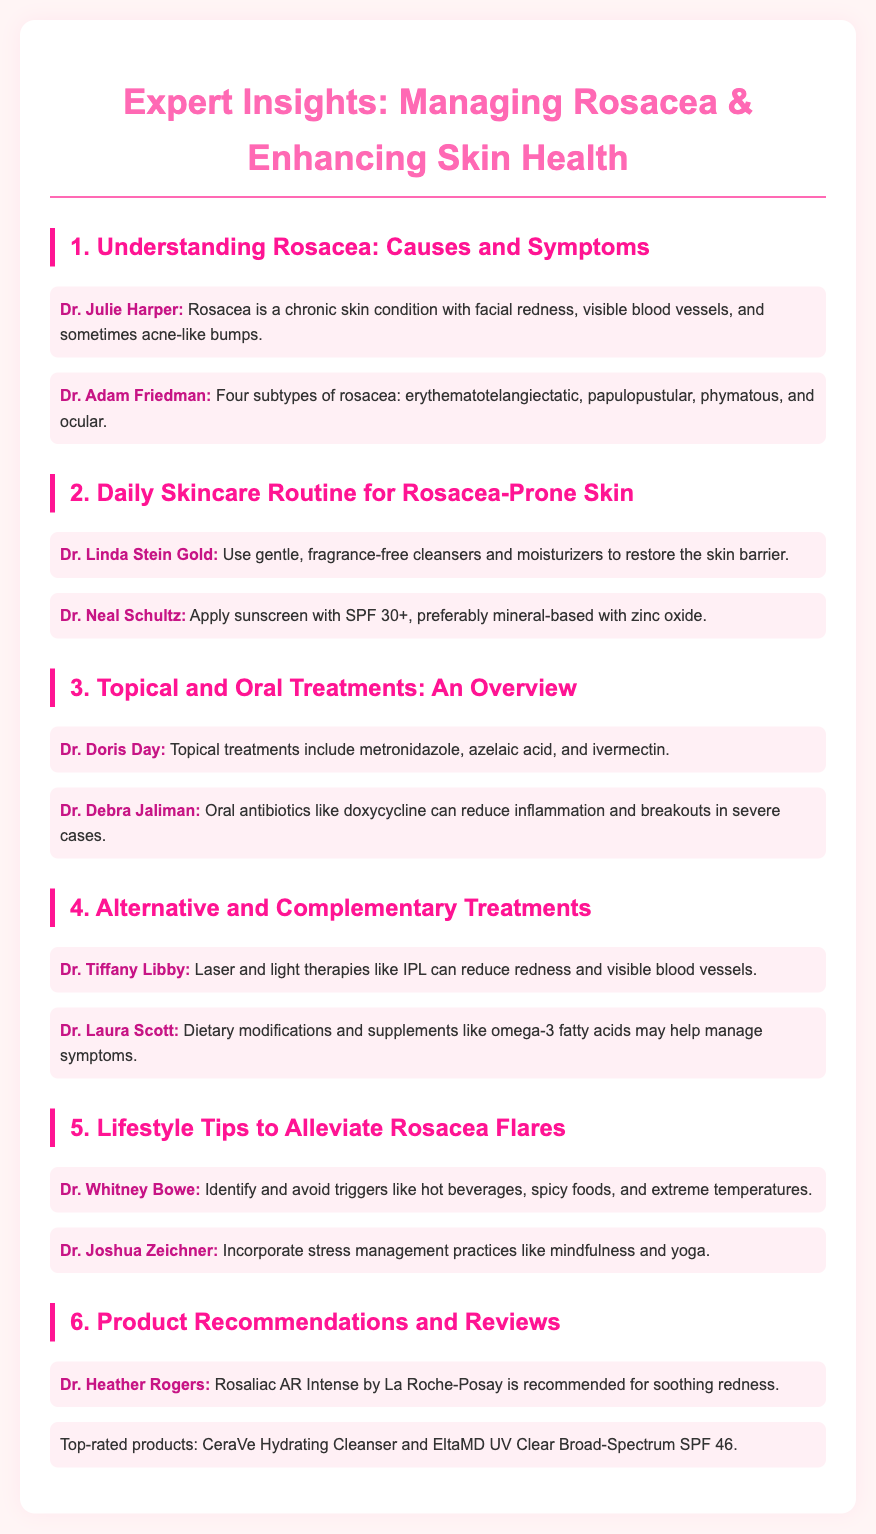what are the four subtypes of rosacea? The document lists the four subtypes of rosacea mentioned by Dr. Adam Friedman: erythematotelangiectatic, papulopustular, phymatous, and ocular.
Answer: erythematotelangiectatic, papulopustular, phymatous, ocular who recommends Rosaliac AR Intense? Dr. Heather Rogers specifically mentions the product Rosaliac AR Intense as a recommendation for soothing redness in rosacea-prone skin.
Answer: Dr. Heather Rogers what type of sunscreen is recommended for rosacea-prone skin? Dr. Neal Schultz recommends applying sunscreen with SPF 30+, preferably mineral-based with zinc oxide, for protecting rosacea-prone skin.
Answer: mineral-based with zinc oxide which therapies can help reduce redness and visible blood vessels? Dr. Tiffany Libby refers to laser and light therapies like IPL as options that can reduce redness and visible blood vessels in rosacea patients.
Answer: IPL what lifestyle change can help alleviate rosacea flares? Dr. Whitney Bowe suggests identifying and avoiding triggers like hot beverages, spicy foods, and extreme temperatures as a lifestyle change to help alleviate rosacea flares.
Answer: avoid triggers what is a recommended oral antibiotic for severe rosacea? Dr. Debra Jaliman mentions doxycycline as an oral antibiotic that can reduce inflammation and breakouts in severe rosacea cases.
Answer: doxycycline 